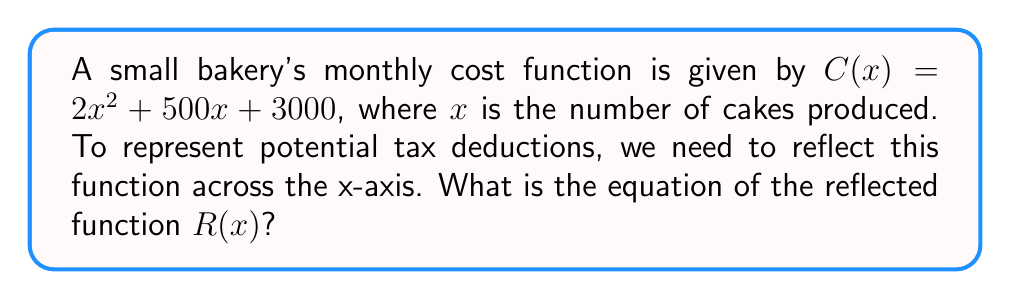Solve this math problem. To reflect a function across the x-axis, we multiply the entire function by -1. This process effectively flips the function upside down. Here's how we do it step-by-step:

1. Start with the original cost function:
   $C(x) = 2x^2 + 500x + 3000$

2. Multiply the entire function by -1:
   $R(x) = -1 \cdot (2x^2 + 500x + 3000)$

3. Distribute the negative sign:
   $R(x) = -2x^2 - 500x - 3000$

This new function $R(x)$ represents the reflection of the original cost function across the x-axis. In the context of tax deductions, this could be interpreted as the potential savings or deductions a bakery might claim based on their production costs.
Answer: $R(x) = -2x^2 - 500x - 3000$ 